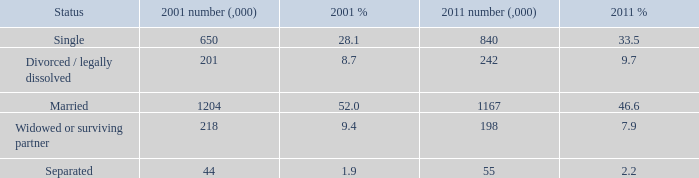What is the lowest 2011 number (,000)? 55.0. 